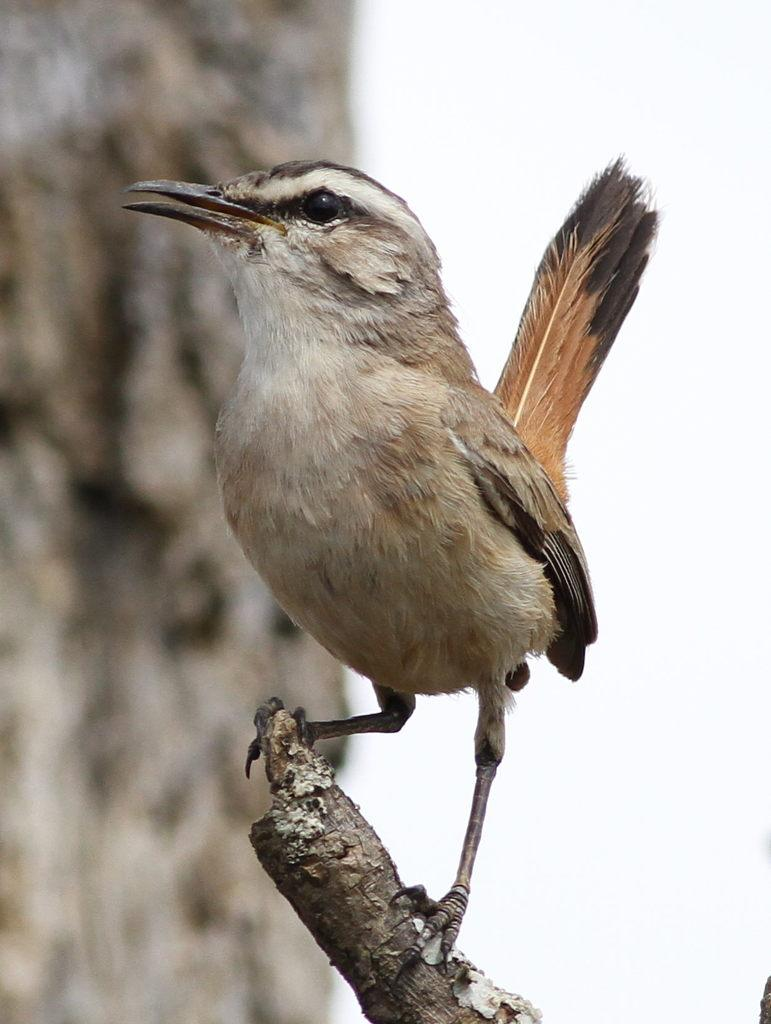What type of animal can be seen in the image? There is a bird in the image. Where is the bird located? The bird is standing on a branch. Can you describe the background of the image? The background of the image is blurred. What type of carriage can be seen in the image? There is no carriage present in the image; it features a bird standing on a branch with a blurred background. 